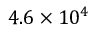<formula> <loc_0><loc_0><loc_500><loc_500>4 . 6 \times 1 0 ^ { 4 }</formula> 